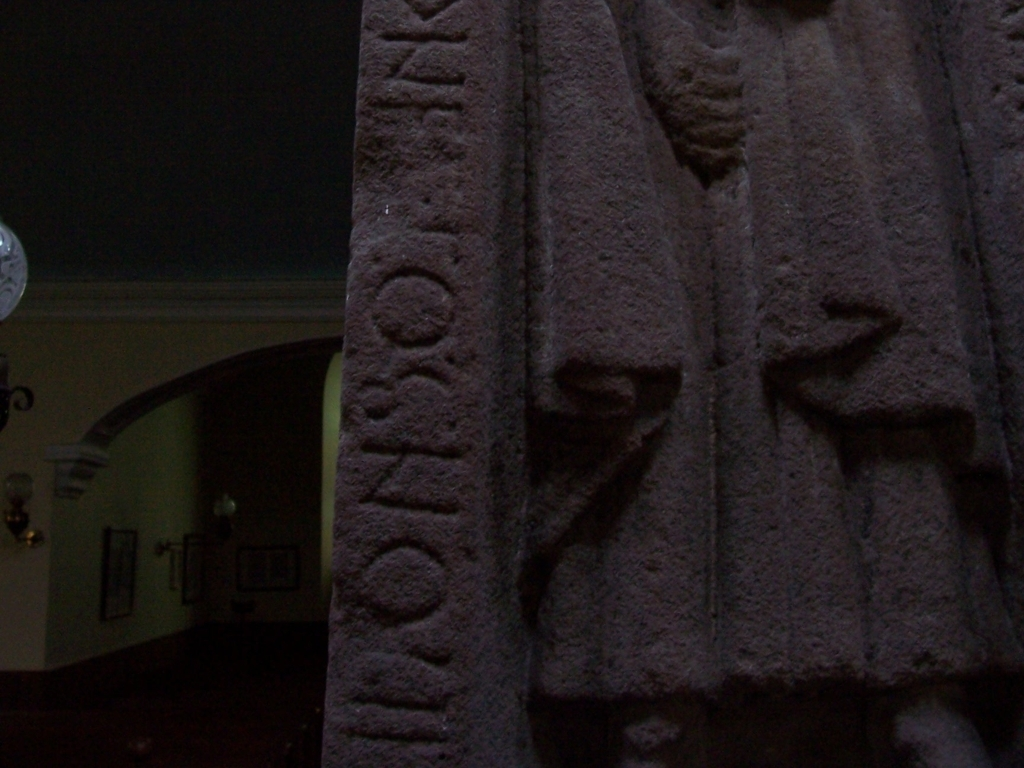How are the relief lines and textual symbols in this image?
A. still acceptable
B. impressive
C. unreadable The relief lines and textual symbols in this image are clear enough to classify the condition as still acceptable (A). Although environmental factors may have led to some wear and dimming of contrast, the carvings remain appreciable, preserving the integrity of both text and imagery. 